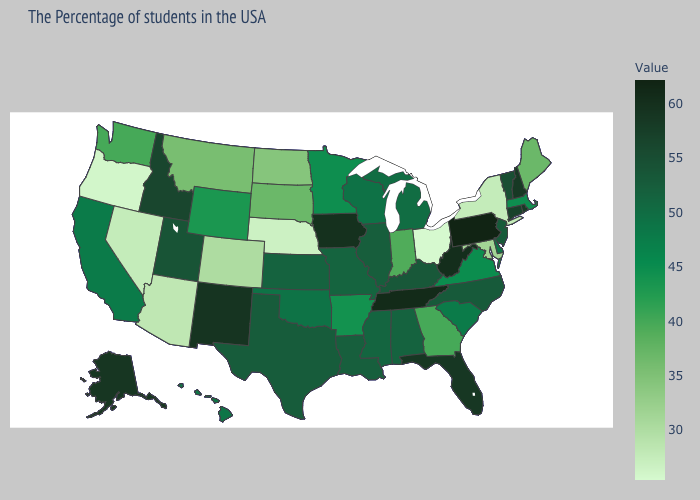Does Massachusetts have a higher value than Maine?
Concise answer only. Yes. Among the states that border Minnesota , does North Dakota have the lowest value?
Answer briefly. Yes. Does Montana have a lower value than Oregon?
Answer briefly. No. Among the states that border Montana , which have the highest value?
Concise answer only. Idaho. 